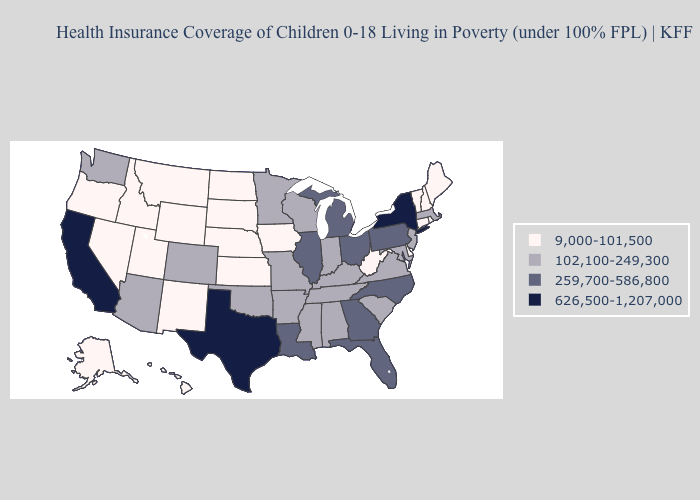Which states have the lowest value in the USA?
Keep it brief. Alaska, Connecticut, Delaware, Hawaii, Idaho, Iowa, Kansas, Maine, Montana, Nebraska, Nevada, New Hampshire, New Mexico, North Dakota, Oregon, Rhode Island, South Dakota, Utah, Vermont, West Virginia, Wyoming. What is the lowest value in states that border Kansas?
Keep it brief. 9,000-101,500. Name the states that have a value in the range 259,700-586,800?
Keep it brief. Florida, Georgia, Illinois, Louisiana, Michigan, North Carolina, Ohio, Pennsylvania. Among the states that border Texas , which have the highest value?
Concise answer only. Louisiana. What is the value of Indiana?
Be succinct. 102,100-249,300. Does Idaho have the same value as North Dakota?
Short answer required. Yes. Name the states that have a value in the range 626,500-1,207,000?
Concise answer only. California, New York, Texas. Name the states that have a value in the range 102,100-249,300?
Write a very short answer. Alabama, Arizona, Arkansas, Colorado, Indiana, Kentucky, Maryland, Massachusetts, Minnesota, Mississippi, Missouri, New Jersey, Oklahoma, South Carolina, Tennessee, Virginia, Washington, Wisconsin. What is the value of Iowa?
Give a very brief answer. 9,000-101,500. Which states have the lowest value in the USA?
Be succinct. Alaska, Connecticut, Delaware, Hawaii, Idaho, Iowa, Kansas, Maine, Montana, Nebraska, Nevada, New Hampshire, New Mexico, North Dakota, Oregon, Rhode Island, South Dakota, Utah, Vermont, West Virginia, Wyoming. Which states have the lowest value in the South?
Short answer required. Delaware, West Virginia. What is the highest value in the USA?
Write a very short answer. 626,500-1,207,000. Does the map have missing data?
Short answer required. No. What is the lowest value in the West?
Concise answer only. 9,000-101,500. What is the lowest value in the West?
Write a very short answer. 9,000-101,500. 